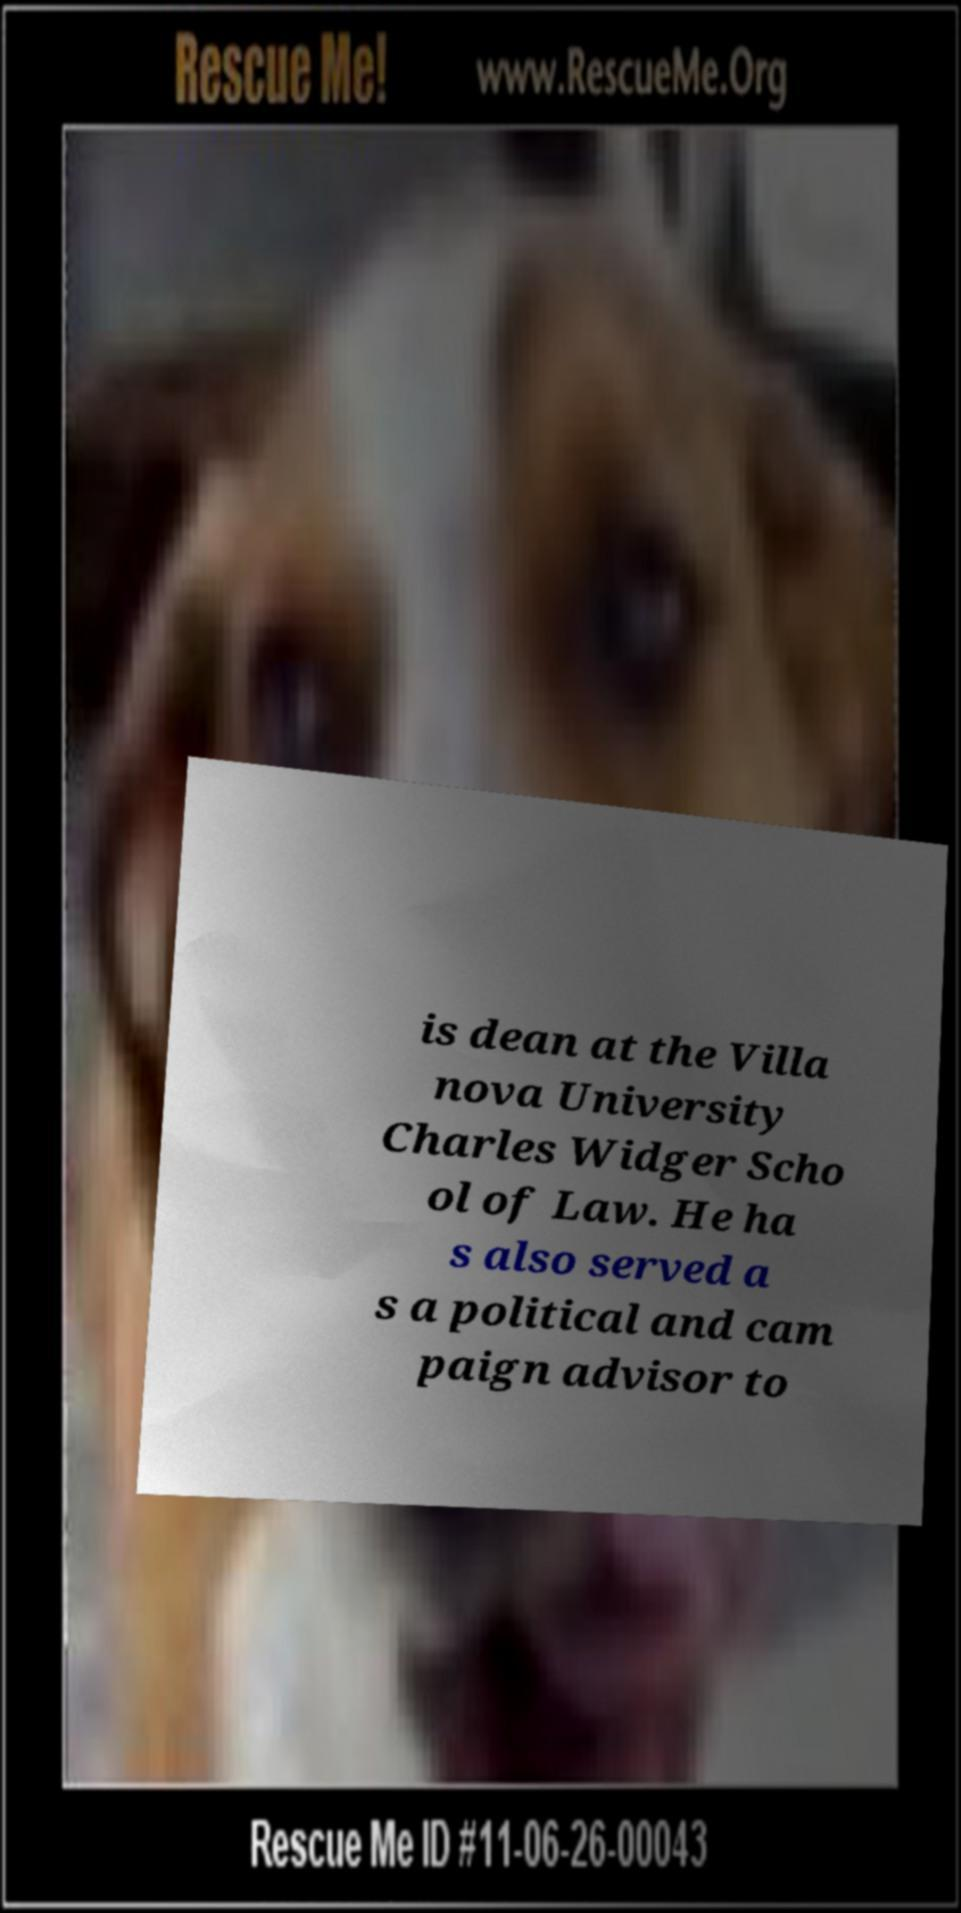I need the written content from this picture converted into text. Can you do that? is dean at the Villa nova University Charles Widger Scho ol of Law. He ha s also served a s a political and cam paign advisor to 